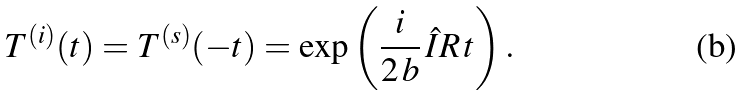<formula> <loc_0><loc_0><loc_500><loc_500>T ^ { ( i ) } ( t ) = T ^ { ( s ) } ( - t ) = \exp \left ( \frac { i } { 2 \, b } \, \hat { I } R \, t \right ) .</formula> 